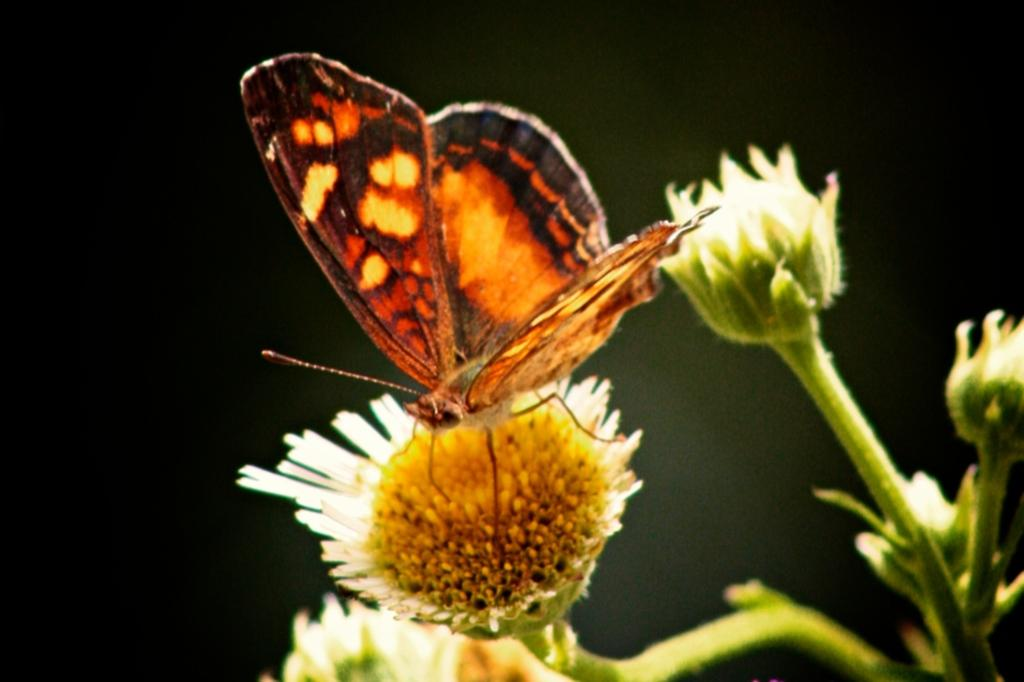What is the main subject of the picture? The main subject of the picture is a butterfly. What is the butterfly doing in the picture? The butterfly is standing on a bud. What can be seen on the right side of the picture? There are flowers on the right side of the picture. What type of plant is present in the picture? There is a plant in the picture. What type of fear does the butterfly have in the picture? There is no indication of fear in the picture, as the butterfly is standing on a bud. What type of cabbage is growing next to the butterfly in the picture? There is no cabbage present in the picture; it features a butterfly, a bud, flowers, and a plant. 